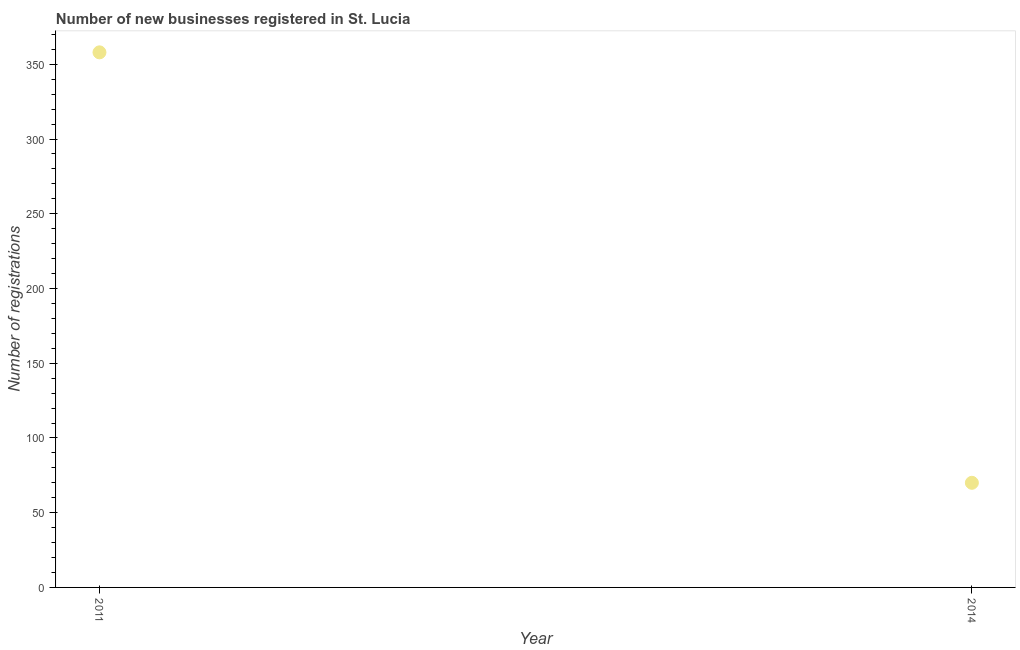What is the number of new business registrations in 2011?
Provide a short and direct response. 358. Across all years, what is the maximum number of new business registrations?
Keep it short and to the point. 358. Across all years, what is the minimum number of new business registrations?
Provide a succinct answer. 70. What is the sum of the number of new business registrations?
Offer a very short reply. 428. What is the difference between the number of new business registrations in 2011 and 2014?
Ensure brevity in your answer.  288. What is the average number of new business registrations per year?
Give a very brief answer. 214. What is the median number of new business registrations?
Ensure brevity in your answer.  214. What is the ratio of the number of new business registrations in 2011 to that in 2014?
Ensure brevity in your answer.  5.11. Is the number of new business registrations in 2011 less than that in 2014?
Offer a very short reply. No. Does the number of new business registrations monotonically increase over the years?
Provide a short and direct response. No. How many years are there in the graph?
Give a very brief answer. 2. What is the title of the graph?
Your answer should be compact. Number of new businesses registered in St. Lucia. What is the label or title of the Y-axis?
Offer a very short reply. Number of registrations. What is the Number of registrations in 2011?
Your answer should be very brief. 358. What is the difference between the Number of registrations in 2011 and 2014?
Ensure brevity in your answer.  288. What is the ratio of the Number of registrations in 2011 to that in 2014?
Provide a short and direct response. 5.11. 